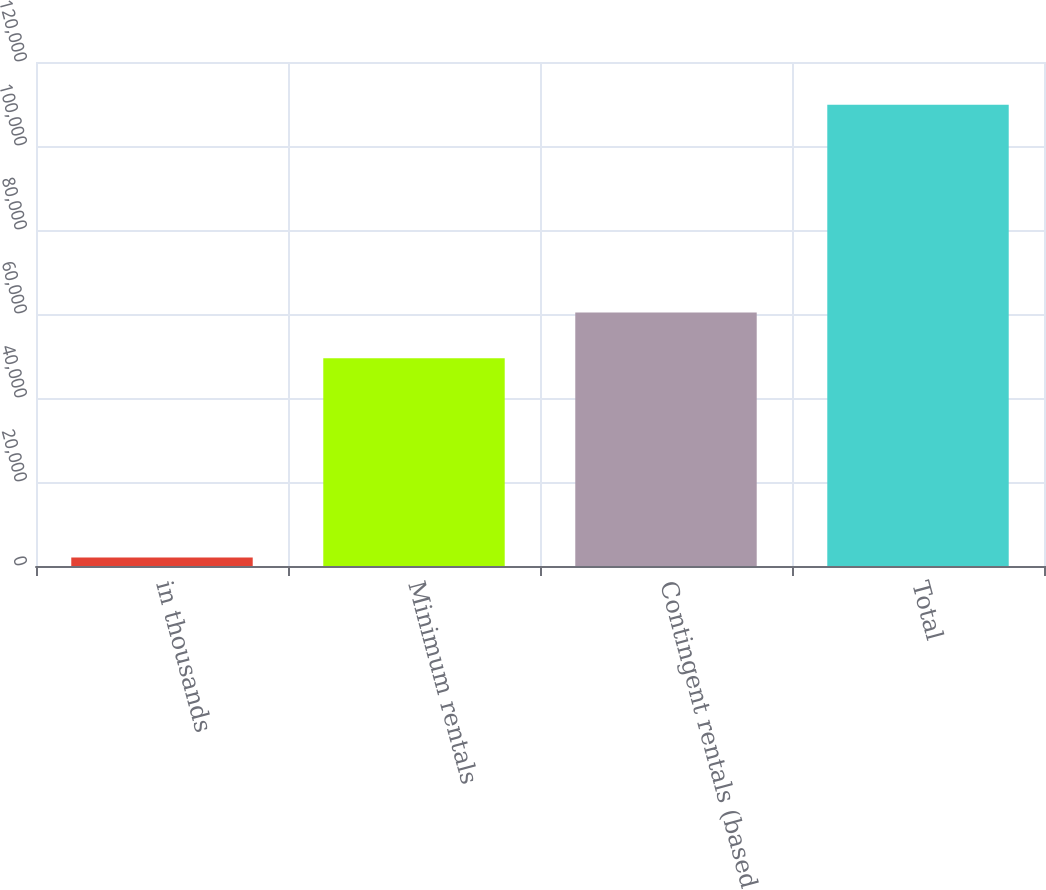<chart> <loc_0><loc_0><loc_500><loc_500><bar_chart><fcel>in thousands<fcel>Minimum rentals<fcel>Contingent rentals (based<fcel>Total<nl><fcel>2015<fcel>49461<fcel>60380<fcel>109841<nl></chart> 